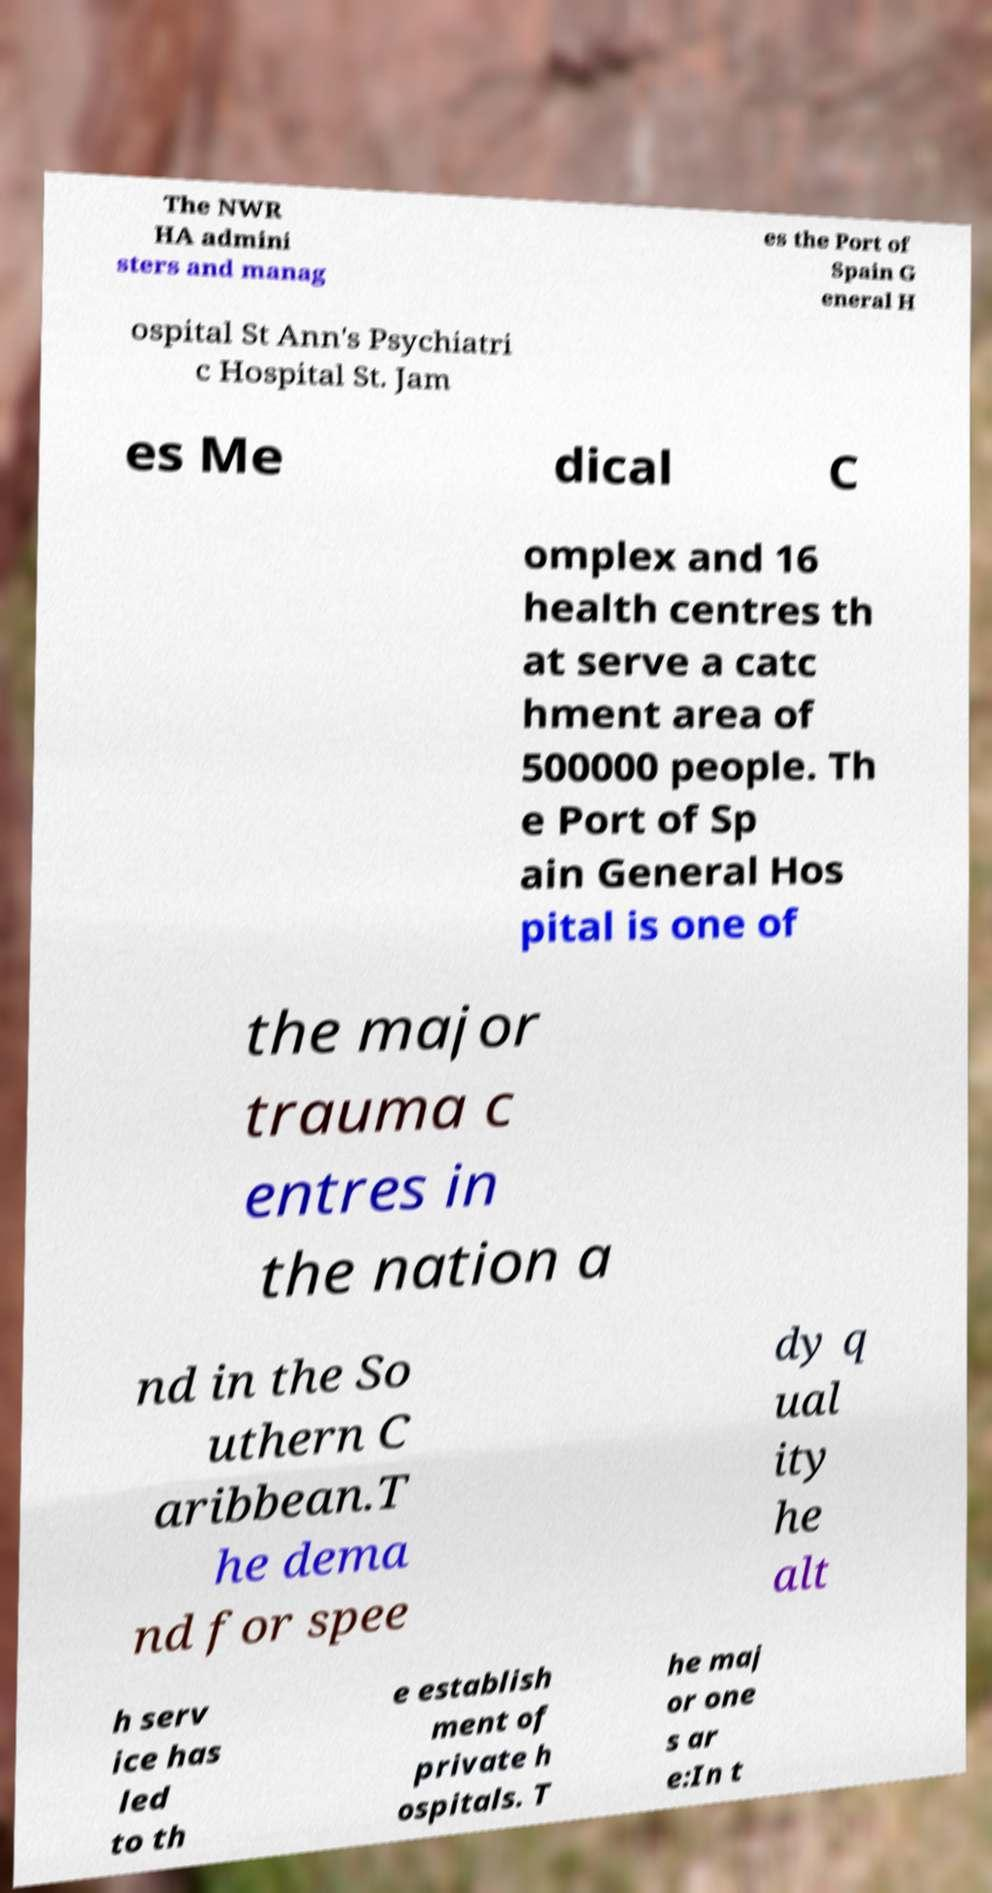Could you extract and type out the text from this image? The NWR HA admini sters and manag es the Port of Spain G eneral H ospital St Ann's Psychiatri c Hospital St. Jam es Me dical C omplex and 16 health centres th at serve a catc hment area of 500000 people. Th e Port of Sp ain General Hos pital is one of the major trauma c entres in the nation a nd in the So uthern C aribbean.T he dema nd for spee dy q ual ity he alt h serv ice has led to th e establish ment of private h ospitals. T he maj or one s ar e:In t 